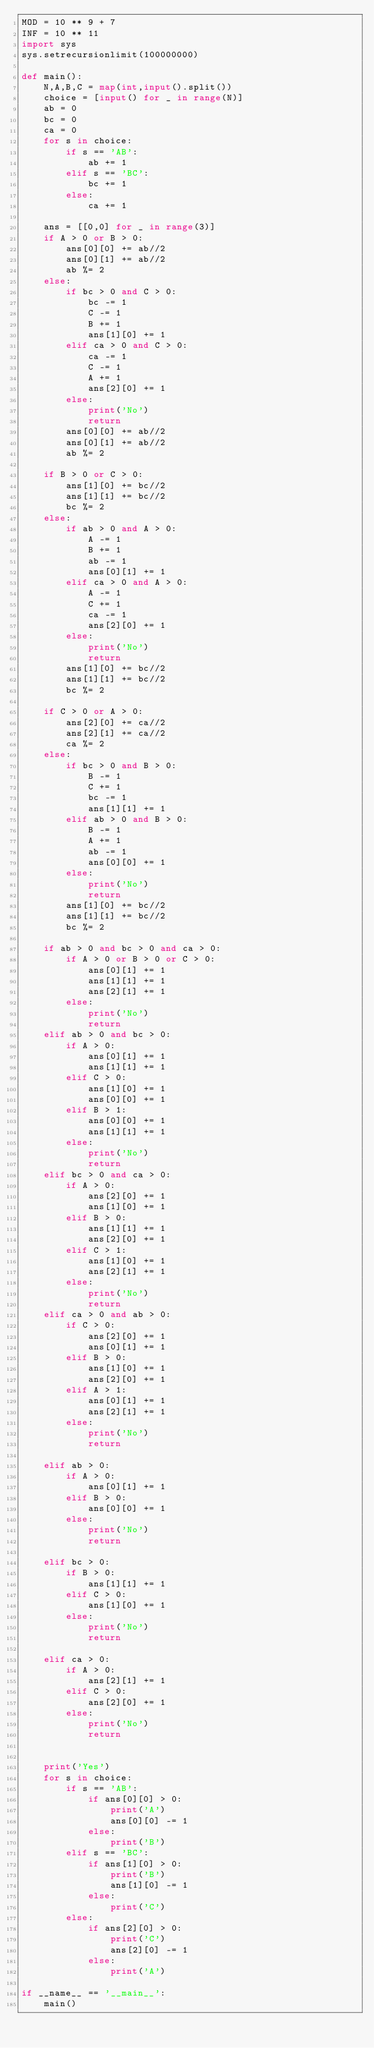Convert code to text. <code><loc_0><loc_0><loc_500><loc_500><_Python_>MOD = 10 ** 9 + 7
INF = 10 ** 11
import sys
sys.setrecursionlimit(100000000)

def main():
    N,A,B,C = map(int,input().split())
    choice = [input() for _ in range(N)]
    ab = 0
    bc = 0
    ca = 0
    for s in choice:
        if s == 'AB':
            ab += 1
        elif s == 'BC':
            bc += 1
        else:
            ca += 1
    
    ans = [[0,0] for _ in range(3)]
    if A > 0 or B > 0:
        ans[0][0] += ab//2
        ans[0][1] += ab//2
        ab %= 2
    else:
        if bc > 0 and C > 0:
            bc -= 1
            C -= 1
            B += 1
            ans[1][0] += 1
        elif ca > 0 and C > 0:
            ca -= 1
            C -= 1
            A += 1
            ans[2][0] += 1
        else:
            print('No')
            return
        ans[0][0] += ab//2
        ans[0][1] += ab//2
        ab %= 2
        
    if B > 0 or C > 0:
        ans[1][0] += bc//2
        ans[1][1] += bc//2
        bc %= 2
    else:
        if ab > 0 and A > 0:
            A -= 1
            B += 1
            ab -= 1
            ans[0][1] += 1
        elif ca > 0 and A > 0:
            A -= 1
            C += 1
            ca -= 1
            ans[2][0] += 1
        else:
            print('No')
            return
        ans[1][0] += bc//2
        ans[1][1] += bc//2
        bc %= 2
                
    if C > 0 or A > 0:
        ans[2][0] += ca//2
        ans[2][1] += ca//2
        ca %= 2
    else:
        if bc > 0 and B > 0:
            B -= 1
            C += 1
            bc -= 1
            ans[1][1] += 1
        elif ab > 0 and B > 0:
            B -= 1
            A += 1
            ab -= 1
            ans[0][0] += 1
        else:
            print('No')
            return
        ans[1][0] += bc//2
        ans[1][1] += bc//2
        bc %= 2
    
    if ab > 0 and bc > 0 and ca > 0:
        if A > 0 or B > 0 or C > 0:
            ans[0][1] += 1
            ans[1][1] += 1
            ans[2][1] += 1
        else:
            print('No')
            return
    elif ab > 0 and bc > 0:
        if A > 0:
            ans[0][1] += 1
            ans[1][1] += 1
        elif C > 0:
            ans[1][0] += 1
            ans[0][0] += 1
        elif B > 1:
            ans[0][0] += 1
            ans[1][1] += 1
        else:
            print('No')
            return
    elif bc > 0 and ca > 0:
        if A > 0:
            ans[2][0] += 1
            ans[1][0] += 1
        elif B > 0:
            ans[1][1] += 1
            ans[2][0] += 1
        elif C > 1:
            ans[1][0] += 1
            ans[2][1] += 1
        else:
            print('No')
            return
    elif ca > 0 and ab > 0:
        if C > 0:
            ans[2][0] += 1
            ans[0][1] += 1
        elif B > 0:
            ans[1][0] += 1
            ans[2][0] += 1
        elif A > 1:
            ans[0][1] += 1
            ans[2][1] += 1
        else:
            print('No')
            return
    
    elif ab > 0:
        if A > 0:
            ans[0][1] += 1
        elif B > 0:
            ans[0][0] += 1
        else:
            print('No')
            return
    
    elif bc > 0:
        if B > 0:
            ans[1][1] += 1
        elif C > 0:
            ans[1][0] += 1
        else:
            print('No')
            return
    
    elif ca > 0:
        if A > 0:
            ans[2][1] += 1
        elif C > 0:
            ans[2][0] += 1
        else:
            print('No')
            return
    

    print('Yes')
    for s in choice:
        if s == 'AB':
            if ans[0][0] > 0:
                print('A')
                ans[0][0] -= 1
            else:
                print('B')
        elif s == 'BC':
            if ans[1][0] > 0:
                print('B')
                ans[1][0] -= 1
            else:
                print('C')
        else:
            if ans[2][0] > 0:
                print('C')
                ans[2][0] -= 1
            else:
                print('A')

if __name__ == '__main__':
    main()
</code> 